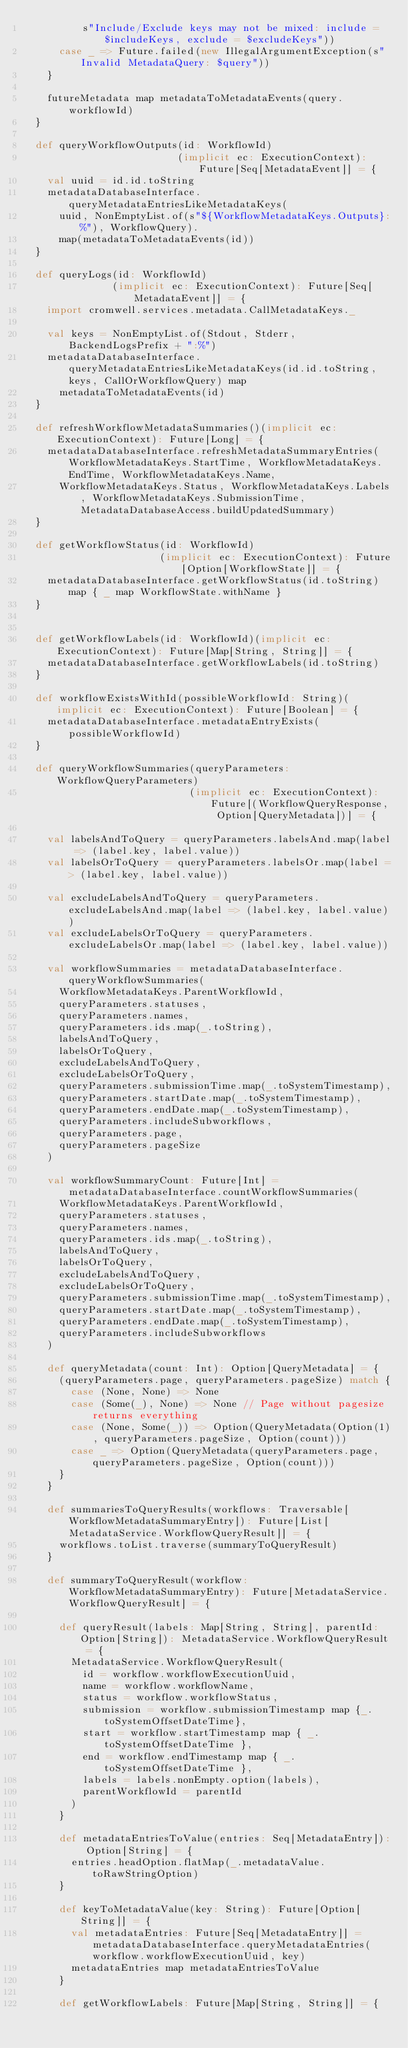<code> <loc_0><loc_0><loc_500><loc_500><_Scala_>          s"Include/Exclude keys may not be mixed: include = $includeKeys, exclude = $excludeKeys"))
      case _ => Future.failed(new IllegalArgumentException(s"Invalid MetadataQuery: $query"))
    }

    futureMetadata map metadataToMetadataEvents(query.workflowId)
  }

  def queryWorkflowOutputs(id: WorkflowId)
                          (implicit ec: ExecutionContext): Future[Seq[MetadataEvent]] = {
    val uuid = id.id.toString
    metadataDatabaseInterface.queryMetadataEntriesLikeMetadataKeys(
      uuid, NonEmptyList.of(s"${WorkflowMetadataKeys.Outputs}:%"), WorkflowQuery).
      map(metadataToMetadataEvents(id))
  }

  def queryLogs(id: WorkflowId)
               (implicit ec: ExecutionContext): Future[Seq[MetadataEvent]] = {
    import cromwell.services.metadata.CallMetadataKeys._

    val keys = NonEmptyList.of(Stdout, Stderr, BackendLogsPrefix + ":%")
    metadataDatabaseInterface.queryMetadataEntriesLikeMetadataKeys(id.id.toString, keys, CallOrWorkflowQuery) map
      metadataToMetadataEvents(id)
  }

  def refreshWorkflowMetadataSummaries()(implicit ec: ExecutionContext): Future[Long] = {
    metadataDatabaseInterface.refreshMetadataSummaryEntries(WorkflowMetadataKeys.StartTime, WorkflowMetadataKeys.EndTime, WorkflowMetadataKeys.Name,
      WorkflowMetadataKeys.Status, WorkflowMetadataKeys.Labels, WorkflowMetadataKeys.SubmissionTime, MetadataDatabaseAccess.buildUpdatedSummary)
  }

  def getWorkflowStatus(id: WorkflowId)
                       (implicit ec: ExecutionContext): Future[Option[WorkflowState]] = {
    metadataDatabaseInterface.getWorkflowStatus(id.toString) map { _ map WorkflowState.withName }
  }


  def getWorkflowLabels(id: WorkflowId)(implicit ec: ExecutionContext): Future[Map[String, String]] = {
    metadataDatabaseInterface.getWorkflowLabels(id.toString)
  }

  def workflowExistsWithId(possibleWorkflowId: String)(implicit ec: ExecutionContext): Future[Boolean] = {
    metadataDatabaseInterface.metadataEntryExists(possibleWorkflowId)
  }

  def queryWorkflowSummaries(queryParameters: WorkflowQueryParameters)
                            (implicit ec: ExecutionContext): Future[(WorkflowQueryResponse, Option[QueryMetadata])] = {

    val labelsAndToQuery = queryParameters.labelsAnd.map(label => (label.key, label.value))
    val labelsOrToQuery = queryParameters.labelsOr.map(label => (label.key, label.value))

    val excludeLabelsAndToQuery = queryParameters.excludeLabelsAnd.map(label => (label.key, label.value))
    val excludeLabelsOrToQuery = queryParameters.excludeLabelsOr.map(label => (label.key, label.value))

    val workflowSummaries = metadataDatabaseInterface.queryWorkflowSummaries(
      WorkflowMetadataKeys.ParentWorkflowId,
      queryParameters.statuses,
      queryParameters.names,
      queryParameters.ids.map(_.toString),
      labelsAndToQuery,
      labelsOrToQuery,
      excludeLabelsAndToQuery,
      excludeLabelsOrToQuery,
      queryParameters.submissionTime.map(_.toSystemTimestamp),
      queryParameters.startDate.map(_.toSystemTimestamp),
      queryParameters.endDate.map(_.toSystemTimestamp),
      queryParameters.includeSubworkflows,
      queryParameters.page,
      queryParameters.pageSize
    )

    val workflowSummaryCount: Future[Int] = metadataDatabaseInterface.countWorkflowSummaries(
      WorkflowMetadataKeys.ParentWorkflowId,
      queryParameters.statuses,
      queryParameters.names,
      queryParameters.ids.map(_.toString),
      labelsAndToQuery,
      labelsOrToQuery,
      excludeLabelsAndToQuery,
      excludeLabelsOrToQuery,
      queryParameters.submissionTime.map(_.toSystemTimestamp),
      queryParameters.startDate.map(_.toSystemTimestamp),
      queryParameters.endDate.map(_.toSystemTimestamp),
      queryParameters.includeSubworkflows
    )

    def queryMetadata(count: Int): Option[QueryMetadata] = {
      (queryParameters.page, queryParameters.pageSize) match {
        case (None, None) => None
        case (Some(_), None) => None // Page without pagesize returns everything
        case (None, Some(_)) => Option(QueryMetadata(Option(1), queryParameters.pageSize, Option(count)))
        case _ => Option(QueryMetadata(queryParameters.page, queryParameters.pageSize, Option(count)))
      }
    }

    def summariesToQueryResults(workflows: Traversable[WorkflowMetadataSummaryEntry]): Future[List[MetadataService.WorkflowQueryResult]] = {
      workflows.toList.traverse(summaryToQueryResult)
    }

    def summaryToQueryResult(workflow: WorkflowMetadataSummaryEntry): Future[MetadataService.WorkflowQueryResult] = {

      def queryResult(labels: Map[String, String], parentId: Option[String]): MetadataService.WorkflowQueryResult = {
        MetadataService.WorkflowQueryResult(
          id = workflow.workflowExecutionUuid,
          name = workflow.workflowName,
          status = workflow.workflowStatus,
          submission = workflow.submissionTimestamp map {_.toSystemOffsetDateTime},
          start = workflow.startTimestamp map { _.toSystemOffsetDateTime },
          end = workflow.endTimestamp map { _.toSystemOffsetDateTime },
          labels = labels.nonEmpty.option(labels),
          parentWorkflowId = parentId
        )
      }

      def metadataEntriesToValue(entries: Seq[MetadataEntry]): Option[String] = {
        entries.headOption.flatMap(_.metadataValue.toRawStringOption)
      }

      def keyToMetadataValue(key: String): Future[Option[String]] = {
        val metadataEntries: Future[Seq[MetadataEntry]] = metadataDatabaseInterface.queryMetadataEntries(workflow.workflowExecutionUuid, key)
        metadataEntries map metadataEntriesToValue
      }

      def getWorkflowLabels: Future[Map[String, String]] = {</code> 